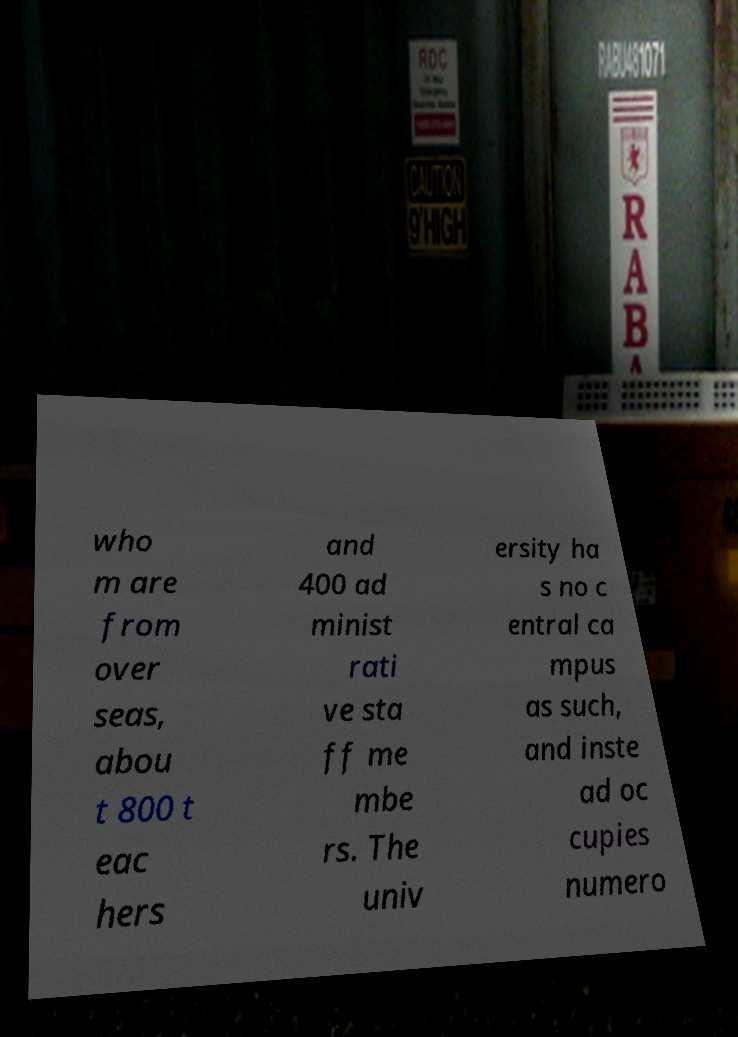Could you assist in decoding the text presented in this image and type it out clearly? who m are from over seas, abou t 800 t eac hers and 400 ad minist rati ve sta ff me mbe rs. The univ ersity ha s no c entral ca mpus as such, and inste ad oc cupies numero 